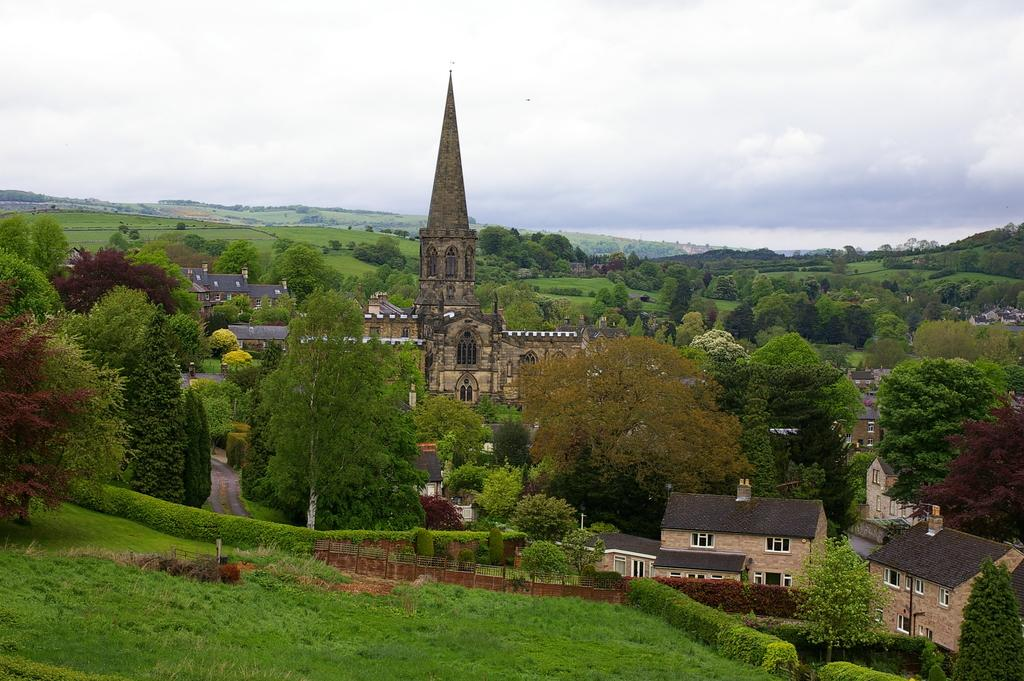What type of structures can be seen in the image? There are buildings in the image. What other natural elements are present in the image? There are plants, trees, and grass in the image. Are there any architectural features visible in the image? Yes, there are windows in the image. What can be seen in the background of the image? The sky is visible in the background of the image, and there are clouds present in the sky. Can you tell me how many pans are being used to cook the grass in the image? There are no pans or cooking activities present in the image; it features buildings, plants, trees, grass, windows, and a sky with clouds. 